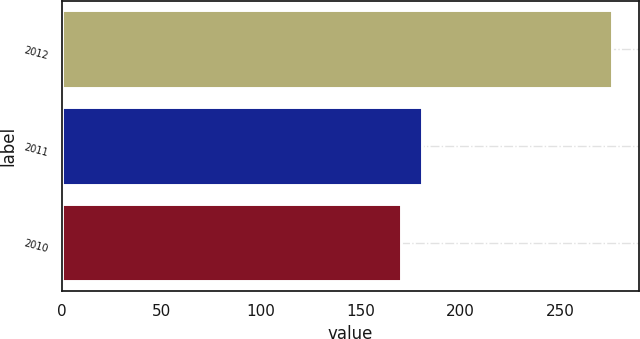<chart> <loc_0><loc_0><loc_500><loc_500><bar_chart><fcel>2012<fcel>2011<fcel>2010<nl><fcel>276<fcel>180.6<fcel>170<nl></chart> 